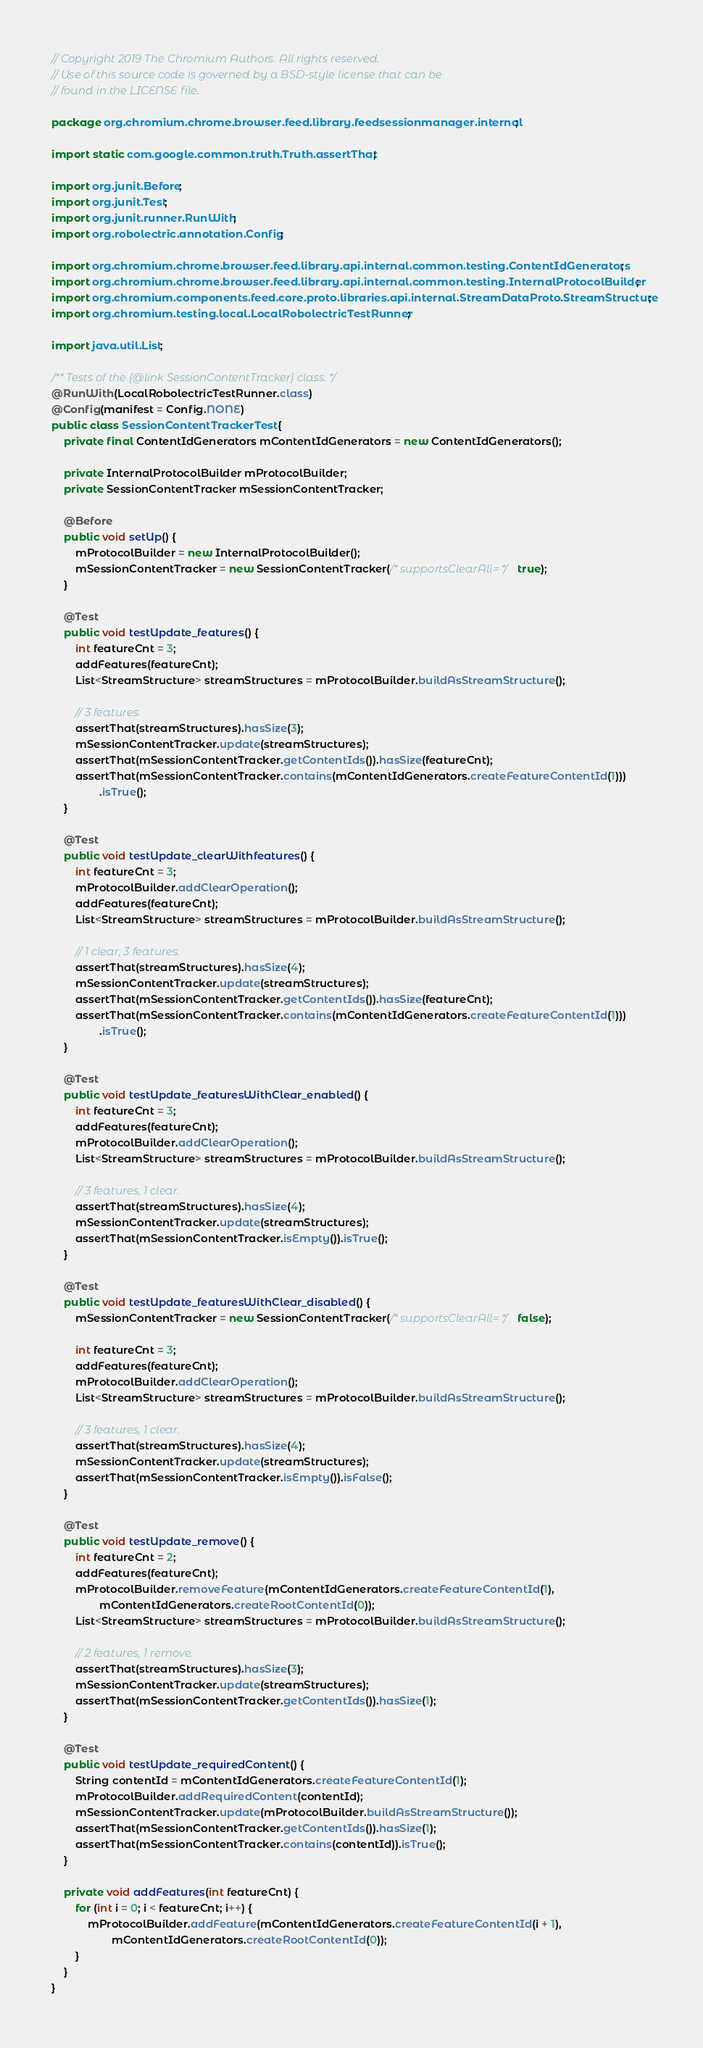Convert code to text. <code><loc_0><loc_0><loc_500><loc_500><_Java_>// Copyright 2019 The Chromium Authors. All rights reserved.
// Use of this source code is governed by a BSD-style license that can be
// found in the LICENSE file.

package org.chromium.chrome.browser.feed.library.feedsessionmanager.internal;

import static com.google.common.truth.Truth.assertThat;

import org.junit.Before;
import org.junit.Test;
import org.junit.runner.RunWith;
import org.robolectric.annotation.Config;

import org.chromium.chrome.browser.feed.library.api.internal.common.testing.ContentIdGenerators;
import org.chromium.chrome.browser.feed.library.api.internal.common.testing.InternalProtocolBuilder;
import org.chromium.components.feed.core.proto.libraries.api.internal.StreamDataProto.StreamStructure;
import org.chromium.testing.local.LocalRobolectricTestRunner;

import java.util.List;

/** Tests of the {@link SessionContentTracker} class. */
@RunWith(LocalRobolectricTestRunner.class)
@Config(manifest = Config.NONE)
public class SessionContentTrackerTest {
    private final ContentIdGenerators mContentIdGenerators = new ContentIdGenerators();

    private InternalProtocolBuilder mProtocolBuilder;
    private SessionContentTracker mSessionContentTracker;

    @Before
    public void setUp() {
        mProtocolBuilder = new InternalProtocolBuilder();
        mSessionContentTracker = new SessionContentTracker(/* supportsClearAll= */ true);
    }

    @Test
    public void testUpdate_features() {
        int featureCnt = 3;
        addFeatures(featureCnt);
        List<StreamStructure> streamStructures = mProtocolBuilder.buildAsStreamStructure();

        // 3 features.
        assertThat(streamStructures).hasSize(3);
        mSessionContentTracker.update(streamStructures);
        assertThat(mSessionContentTracker.getContentIds()).hasSize(featureCnt);
        assertThat(mSessionContentTracker.contains(mContentIdGenerators.createFeatureContentId(1)))
                .isTrue();
    }

    @Test
    public void testUpdate_clearWithfeatures() {
        int featureCnt = 3;
        mProtocolBuilder.addClearOperation();
        addFeatures(featureCnt);
        List<StreamStructure> streamStructures = mProtocolBuilder.buildAsStreamStructure();

        // 1 clear, 3 features.
        assertThat(streamStructures).hasSize(4);
        mSessionContentTracker.update(streamStructures);
        assertThat(mSessionContentTracker.getContentIds()).hasSize(featureCnt);
        assertThat(mSessionContentTracker.contains(mContentIdGenerators.createFeatureContentId(1)))
                .isTrue();
    }

    @Test
    public void testUpdate_featuresWithClear_enabled() {
        int featureCnt = 3;
        addFeatures(featureCnt);
        mProtocolBuilder.addClearOperation();
        List<StreamStructure> streamStructures = mProtocolBuilder.buildAsStreamStructure();

        // 3 features, 1 clear.
        assertThat(streamStructures).hasSize(4);
        mSessionContentTracker.update(streamStructures);
        assertThat(mSessionContentTracker.isEmpty()).isTrue();
    }

    @Test
    public void testUpdate_featuresWithClear_disabled() {
        mSessionContentTracker = new SessionContentTracker(/* supportsClearAll= */ false);

        int featureCnt = 3;
        addFeatures(featureCnt);
        mProtocolBuilder.addClearOperation();
        List<StreamStructure> streamStructures = mProtocolBuilder.buildAsStreamStructure();

        // 3 features, 1 clear.
        assertThat(streamStructures).hasSize(4);
        mSessionContentTracker.update(streamStructures);
        assertThat(mSessionContentTracker.isEmpty()).isFalse();
    }

    @Test
    public void testUpdate_remove() {
        int featureCnt = 2;
        addFeatures(featureCnt);
        mProtocolBuilder.removeFeature(mContentIdGenerators.createFeatureContentId(1),
                mContentIdGenerators.createRootContentId(0));
        List<StreamStructure> streamStructures = mProtocolBuilder.buildAsStreamStructure();

        // 2 features, 1 remove.
        assertThat(streamStructures).hasSize(3);
        mSessionContentTracker.update(streamStructures);
        assertThat(mSessionContentTracker.getContentIds()).hasSize(1);
    }

    @Test
    public void testUpdate_requiredContent() {
        String contentId = mContentIdGenerators.createFeatureContentId(1);
        mProtocolBuilder.addRequiredContent(contentId);
        mSessionContentTracker.update(mProtocolBuilder.buildAsStreamStructure());
        assertThat(mSessionContentTracker.getContentIds()).hasSize(1);
        assertThat(mSessionContentTracker.contains(contentId)).isTrue();
    }

    private void addFeatures(int featureCnt) {
        for (int i = 0; i < featureCnt; i++) {
            mProtocolBuilder.addFeature(mContentIdGenerators.createFeatureContentId(i + 1),
                    mContentIdGenerators.createRootContentId(0));
        }
    }
}
</code> 